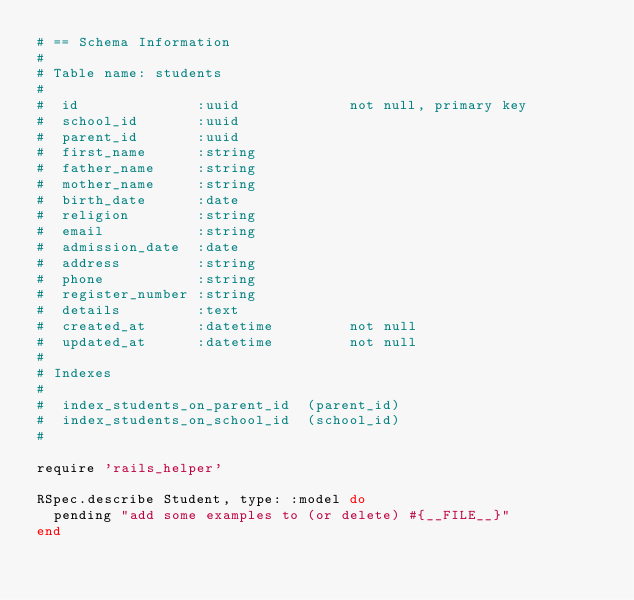<code> <loc_0><loc_0><loc_500><loc_500><_Ruby_># == Schema Information
#
# Table name: students
#
#  id              :uuid             not null, primary key
#  school_id       :uuid
#  parent_id       :uuid
#  first_name      :string
#  father_name     :string
#  mother_name     :string
#  birth_date      :date
#  religion        :string
#  email           :string
#  admission_date  :date
#  address         :string
#  phone           :string
#  register_number :string
#  details         :text
#  created_at      :datetime         not null
#  updated_at      :datetime         not null
#
# Indexes
#
#  index_students_on_parent_id  (parent_id)
#  index_students_on_school_id  (school_id)
#

require 'rails_helper'

RSpec.describe Student, type: :model do
  pending "add some examples to (or delete) #{__FILE__}"
end
</code> 